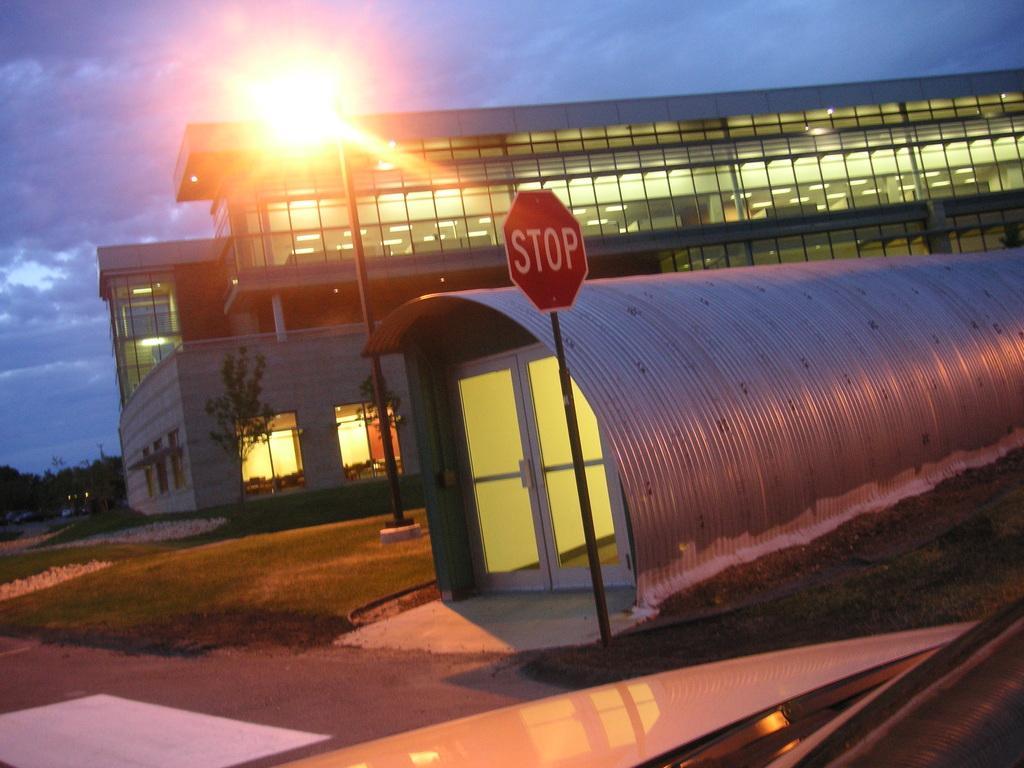<image>
Present a compact description of the photo's key features. Red stop sign outside of a small building. 